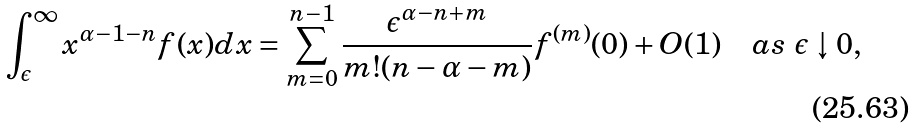Convert formula to latex. <formula><loc_0><loc_0><loc_500><loc_500>\int _ { \epsilon } ^ { \infty } x ^ { \alpha - 1 - n } f ( x ) d x = \sum _ { m = 0 } ^ { n - 1 } \frac { \epsilon ^ { \alpha - n + m } } { m ! ( n - \alpha - m ) } f ^ { ( m ) } ( 0 ) + O ( 1 ) \quad a s \ \epsilon \downarrow 0 ,</formula> 